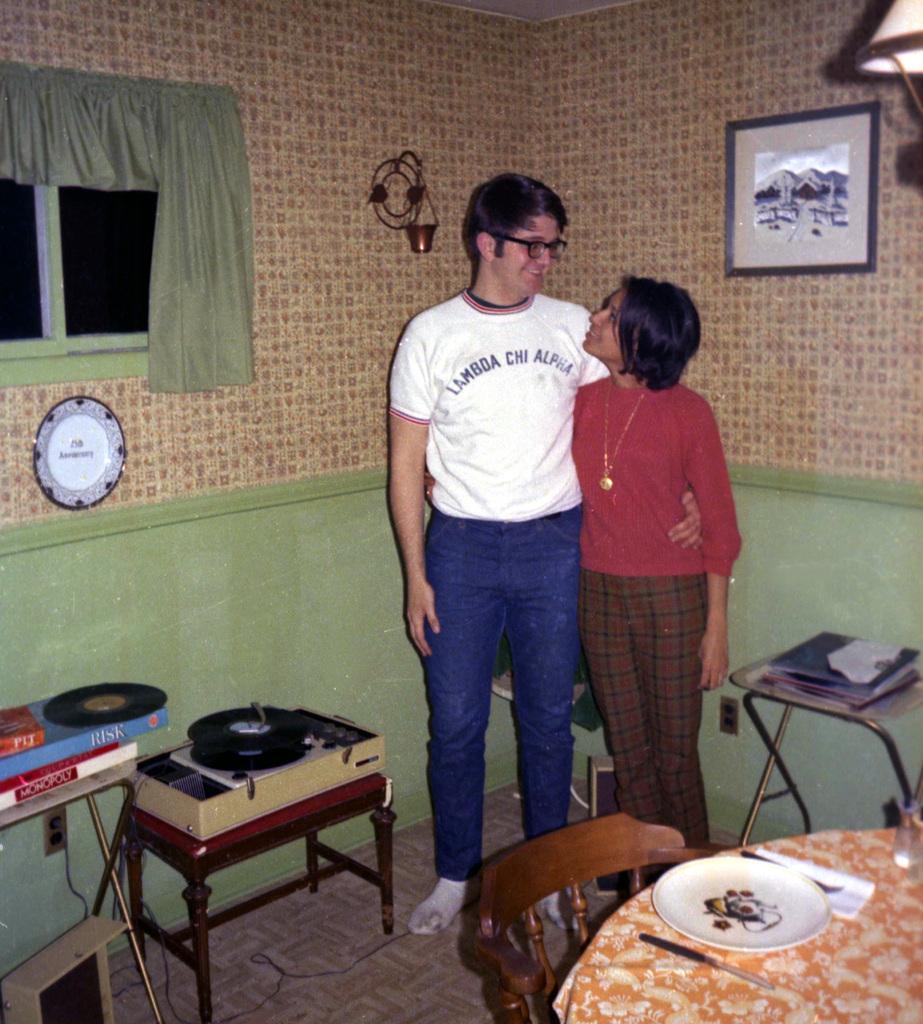What is on the guys shirt?
Give a very brief answer. Lambda chi alpha. What is the last word on his shirt?
Provide a short and direct response. Alpha. 